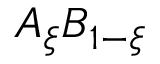Convert formula to latex. <formula><loc_0><loc_0><loc_500><loc_500>A _ { \xi } B _ { 1 - { \xi } }</formula> 